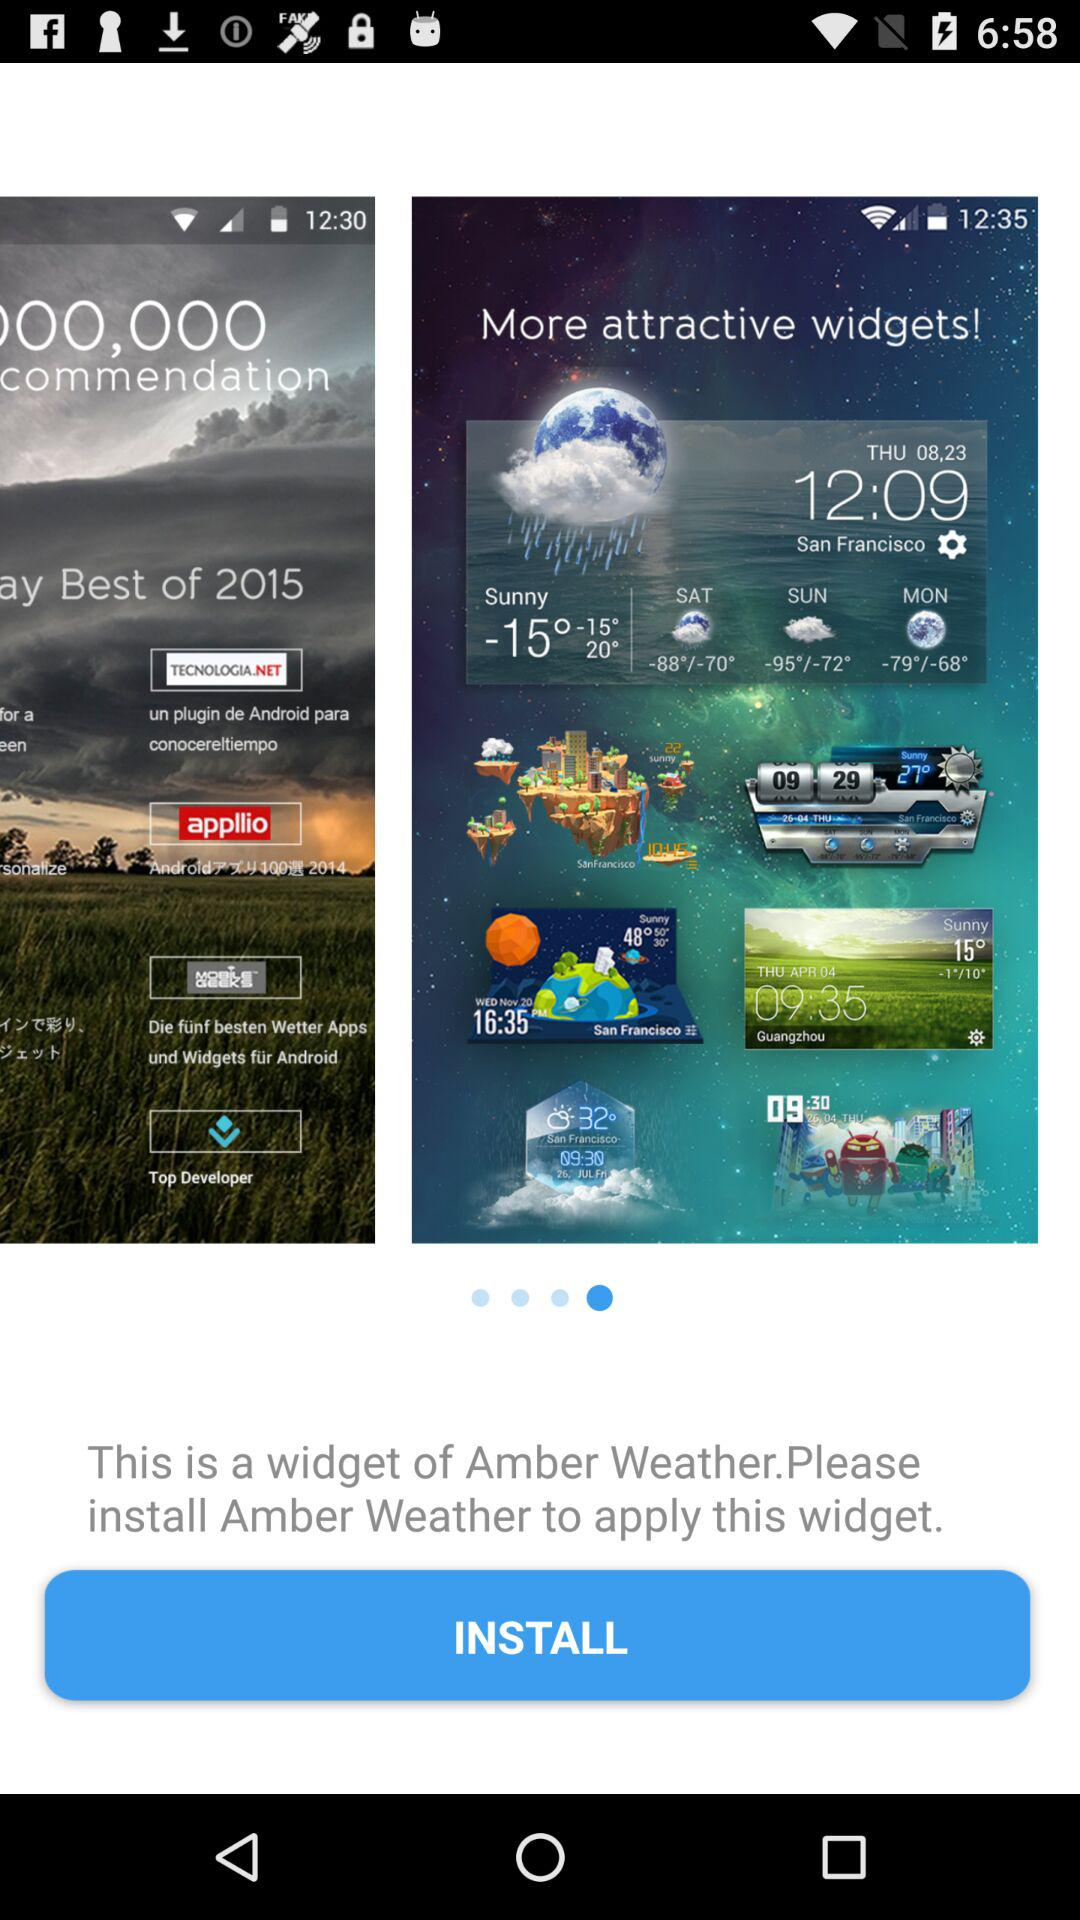What is the current time given in San Francisco?
When the provided information is insufficient, respond with <no answer>. <no answer> 